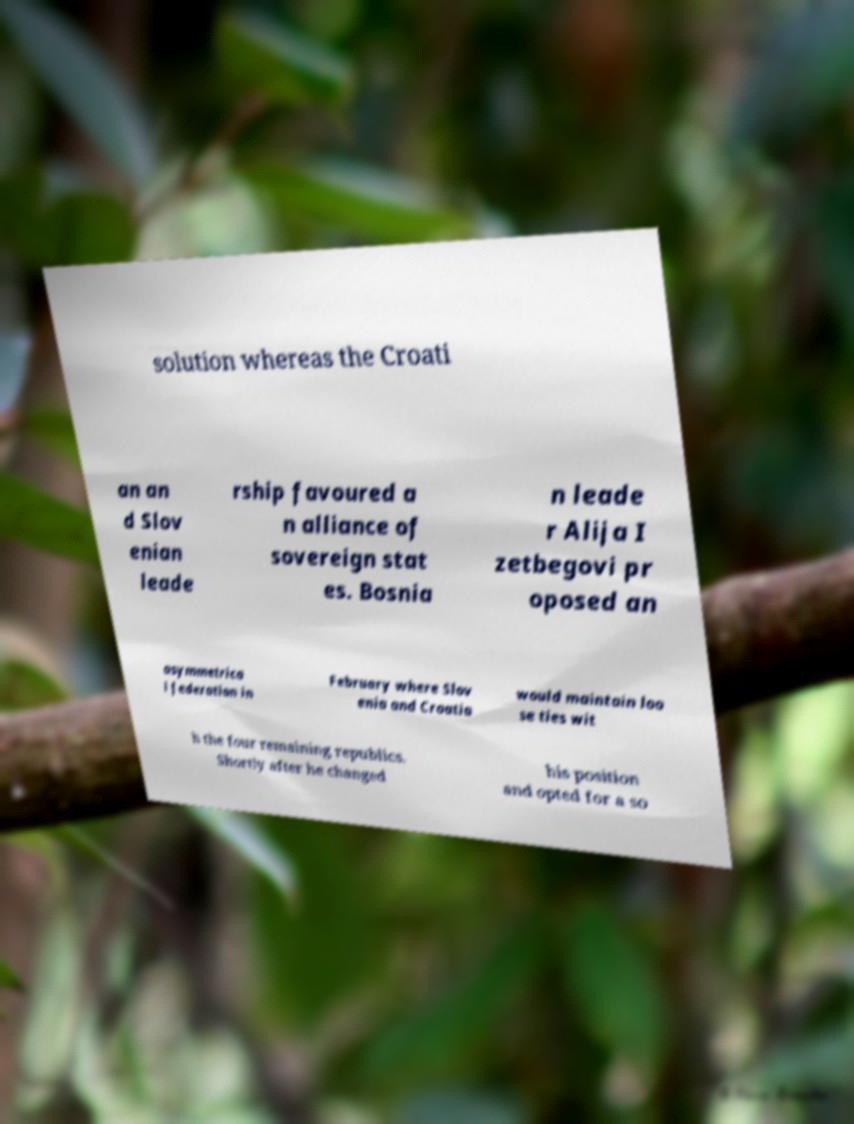Please identify and transcribe the text found in this image. solution whereas the Croati an an d Slov enian leade rship favoured a n alliance of sovereign stat es. Bosnia n leade r Alija I zetbegovi pr oposed an asymmetrica l federation in February where Slov enia and Croatia would maintain loo se ties wit h the four remaining republics. Shortly after he changed his position and opted for a so 